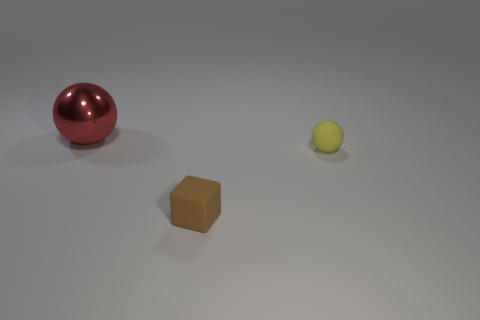There is a matte thing that is behind the brown thing; does it have the same size as the rubber thing that is left of the yellow matte object?
Ensure brevity in your answer.  Yes. What number of things are either tiny blue shiny blocks or spheres in front of the red shiny object?
Make the answer very short. 1. What is the color of the block?
Your answer should be compact. Brown. There is a sphere to the left of the tiny rubber thing that is in front of the small object that is on the right side of the brown block; what is its material?
Your answer should be very brief. Metal. Are there any big metal things that have the same color as the tiny rubber sphere?
Give a very brief answer. No. Does the block have the same size as the object to the right of the cube?
Your answer should be compact. Yes. There is a small rubber cube that is in front of the sphere on the right side of the big red metal ball; how many large shiny spheres are right of it?
Your response must be concise. 0. Are there any large red metallic balls in front of the yellow matte ball?
Give a very brief answer. No. There is a red object; what shape is it?
Offer a very short reply. Sphere. There is a small object behind the tiny block in front of the sphere that is to the right of the big object; what shape is it?
Provide a short and direct response. Sphere. 